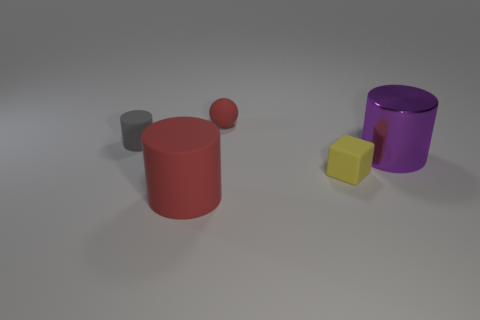Subtract all shiny cylinders. How many cylinders are left? 2 Add 4 big shiny cylinders. How many objects exist? 9 Subtract all purple cylinders. How many cylinders are left? 2 Subtract 0 gray blocks. How many objects are left? 5 Subtract all cylinders. How many objects are left? 2 Subtract all cyan balls. Subtract all yellow blocks. How many balls are left? 1 Subtract all purple cubes. How many purple cylinders are left? 1 Subtract all tiny red rubber objects. Subtract all gray cylinders. How many objects are left? 3 Add 1 small cylinders. How many small cylinders are left? 2 Add 5 rubber spheres. How many rubber spheres exist? 6 